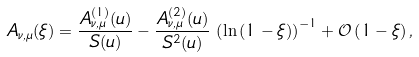Convert formula to latex. <formula><loc_0><loc_0><loc_500><loc_500>A _ { \nu , \mu } ( \xi ) = \frac { A _ { \nu , \mu } ^ { ( 1 ) } ( u ) } { S ( u ) } - \frac { A _ { \nu , \mu } ^ { ( 2 ) } ( u ) } { S ^ { 2 } ( u ) } \, \left ( \ln { ( 1 - \xi ) } \right ) ^ { - 1 } + { \mathcal { O } } \left ( 1 - \xi \right ) ,</formula> 